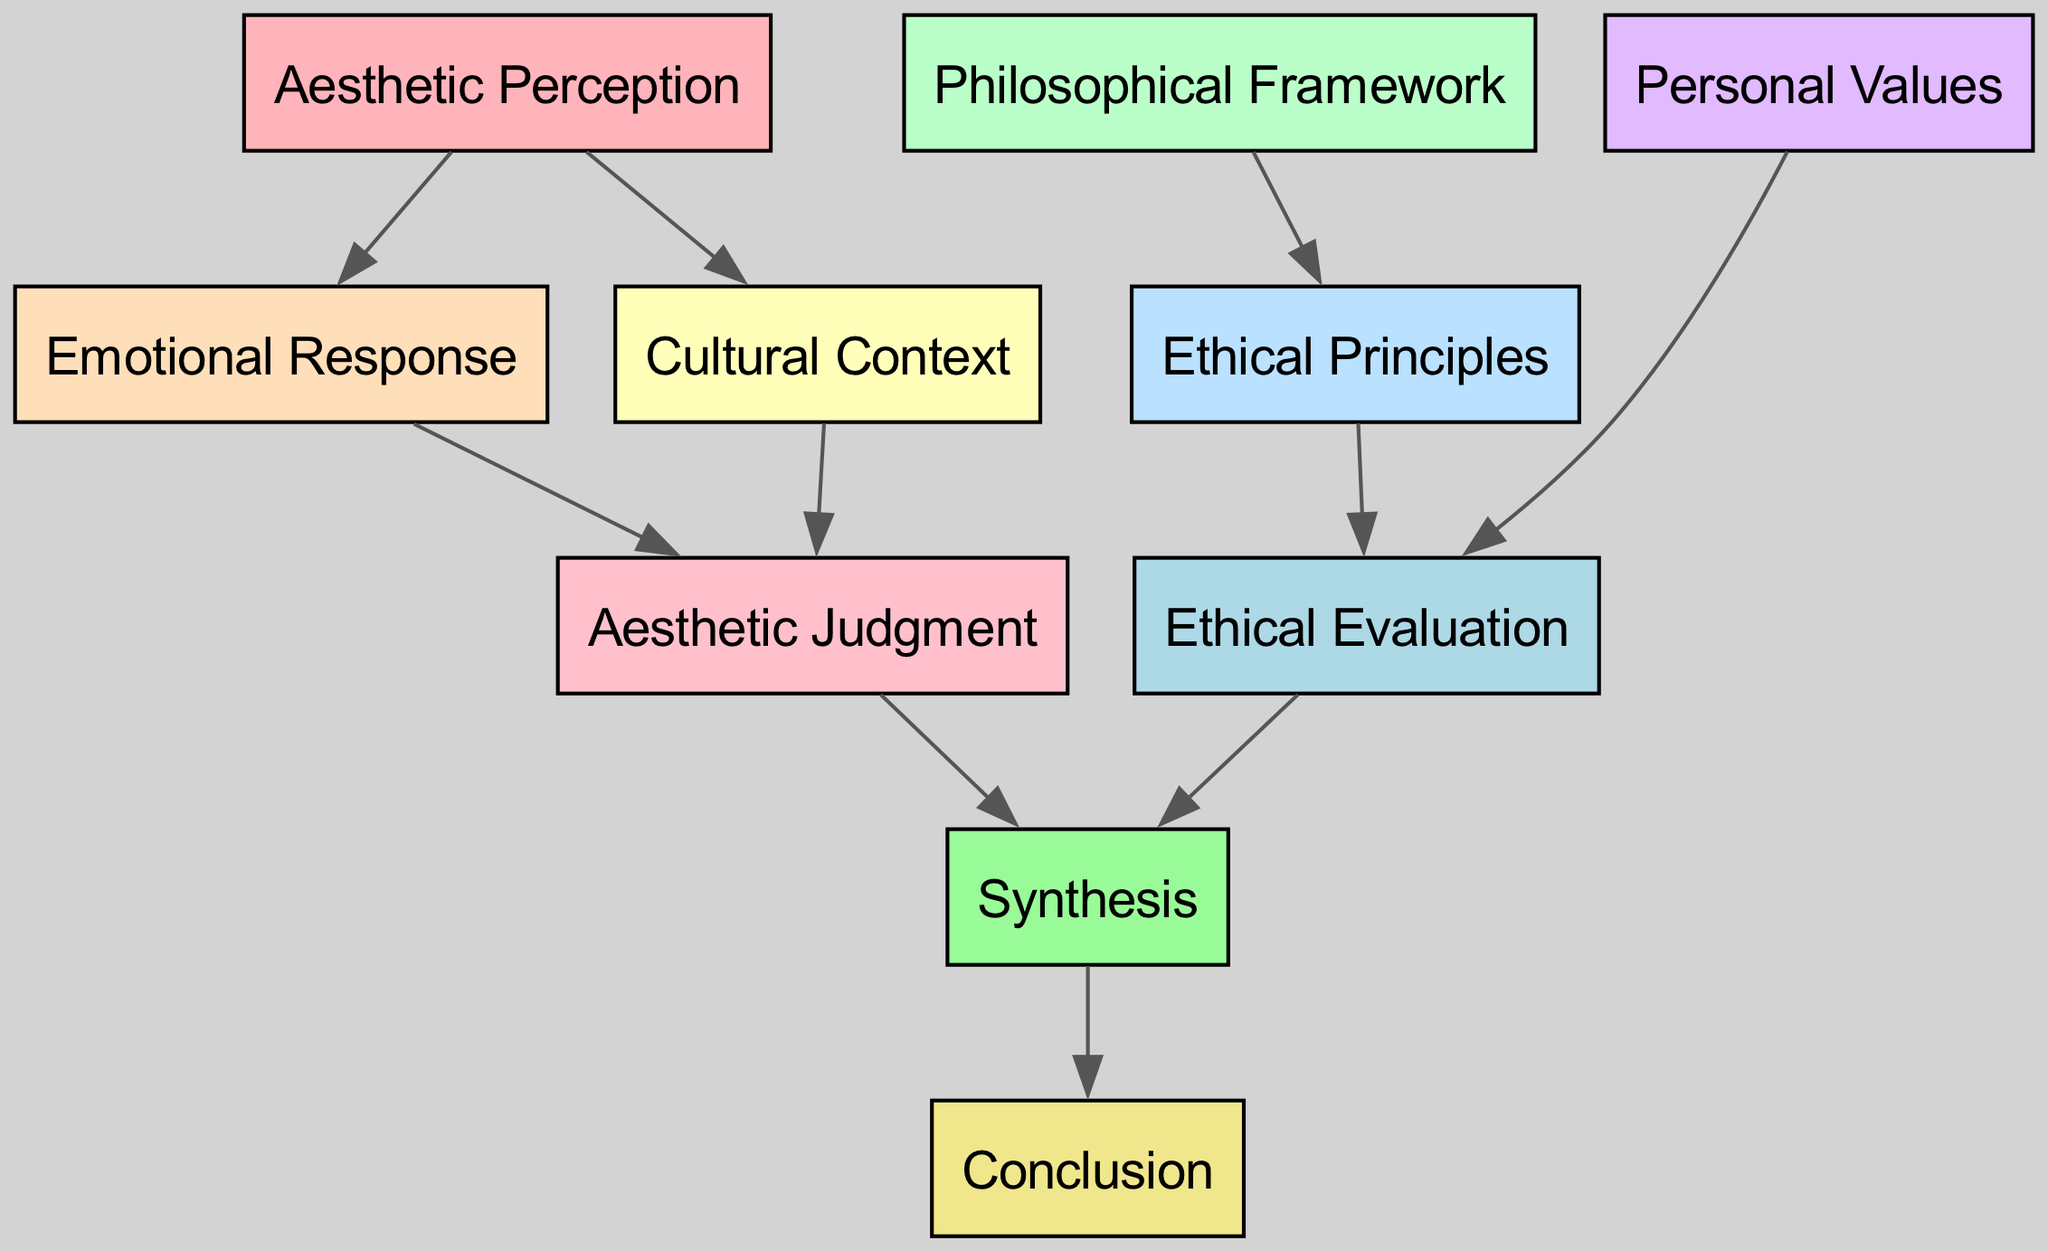What is the total number of nodes in this diagram? The diagram lists 10 distinct nodes including "Aesthetic Perception," "Emotional Response," "Cultural Context," "Philosophical Framework," "Ethical Principles," "Personal Values," "Aesthetic Judgment," "Ethical Evaluation," "Synthesis," and "Conclusion." Counting all of these gives a total of 10 nodes.
Answer: 10 Which node connects directly to both "Aesthetic Judgment" and "Synthesis"? By observing the edges, "Ethical Evaluation" connects directly to "Aesthetic Judgment" and also connects to "Synthesis." Therefore, the node that is directly linked to both is "Ethical Evaluation."
Answer: Ethical Evaluation How many edges lead from "Cultural Context"? Looking at the diagram, "Cultural Context" has one outgoing edge that connects to "Aesthetic Judgment." Thus, there is a total of 1 edge leading from "Cultural Context."
Answer: 1 What is the first node in the flow leading to "Conclusion"? The flow leading to "Conclusion" starts from "Synthesis." The transition is from "Synthesis" to "Conclusion," making "Synthesis" the first node in the flow leading to the final conclusion.
Answer: Synthesis Which two nodes contribute to "Aesthetic Judgment"? The diagram shows two incoming edges to "Aesthetic Judgment" from "Emotional Response" and "Cultural Context." Thus, the two nodes that contribute to "Aesthetic Judgment" are "Emotional Response" and "Cultural Context."
Answer: Emotional Response, Cultural Context What is the relationship between "Philosophical Framework" and "Ethical Principles"? The relationship is defined by a directed edge that flows from "Philosophical Framework" to "Ethical Principles," indicating that the philosophical framework informs the ethical principles. This shows a direct influence.
Answer: Influences Which nodes are at the same rank (level) in the diagram? The nodes at the same rank include "Aesthetic Perception," "Philosophical Framework," and "Personal Values," as they are grouped together in the same subgraph indicating their equal level.
Answer: Aesthetic Perception, Philosophical Framework, Personal Values How does "Emotional Response" impact the "Aesthetic Judgment"? "Emotional Response" directly impacts "Aesthetic Judgment" as evidenced by the directed edge from "Emotional Response" to "Aesthetic Judgment." This means that emotional reactions play a role in forming aesthetic judgments.
Answer: Direct Impact What node precedes "Synthesis" in the flow? "Aesthetic Judgment" and "Ethical Evaluation" both immediately precede "Synthesis," as they both have edges leading towards "Synthesis." Therefore, the nodes that come before "Synthesis" are those two.
Answer: Aesthetic Judgment, Ethical Evaluation 